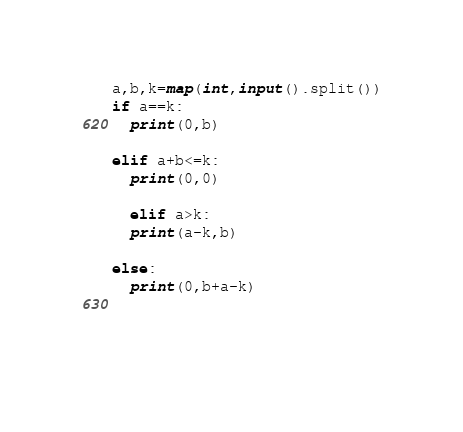Convert code to text. <code><loc_0><loc_0><loc_500><loc_500><_Python_>a,b,k=map(int,input().split())
if a==k:
  print(0,b)

elif a+b<=k:
  print(0,0)

  elif a>k:
  print(a-k,b)
  
else:
  print(0,b+a-k)
  
  
  
</code> 